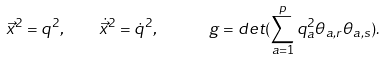<formula> <loc_0><loc_0><loc_500><loc_500>\vec { x } ^ { 2 } = { q } ^ { 2 } , \quad \dot { \vec { x } } ^ { 2 } = \dot { q } ^ { 2 } , \quad \ \ g = d e t ( \sum _ { a = 1 } ^ { p } q _ { a } ^ { 2 } \theta _ { a , r } \theta _ { a , s } ) .</formula> 